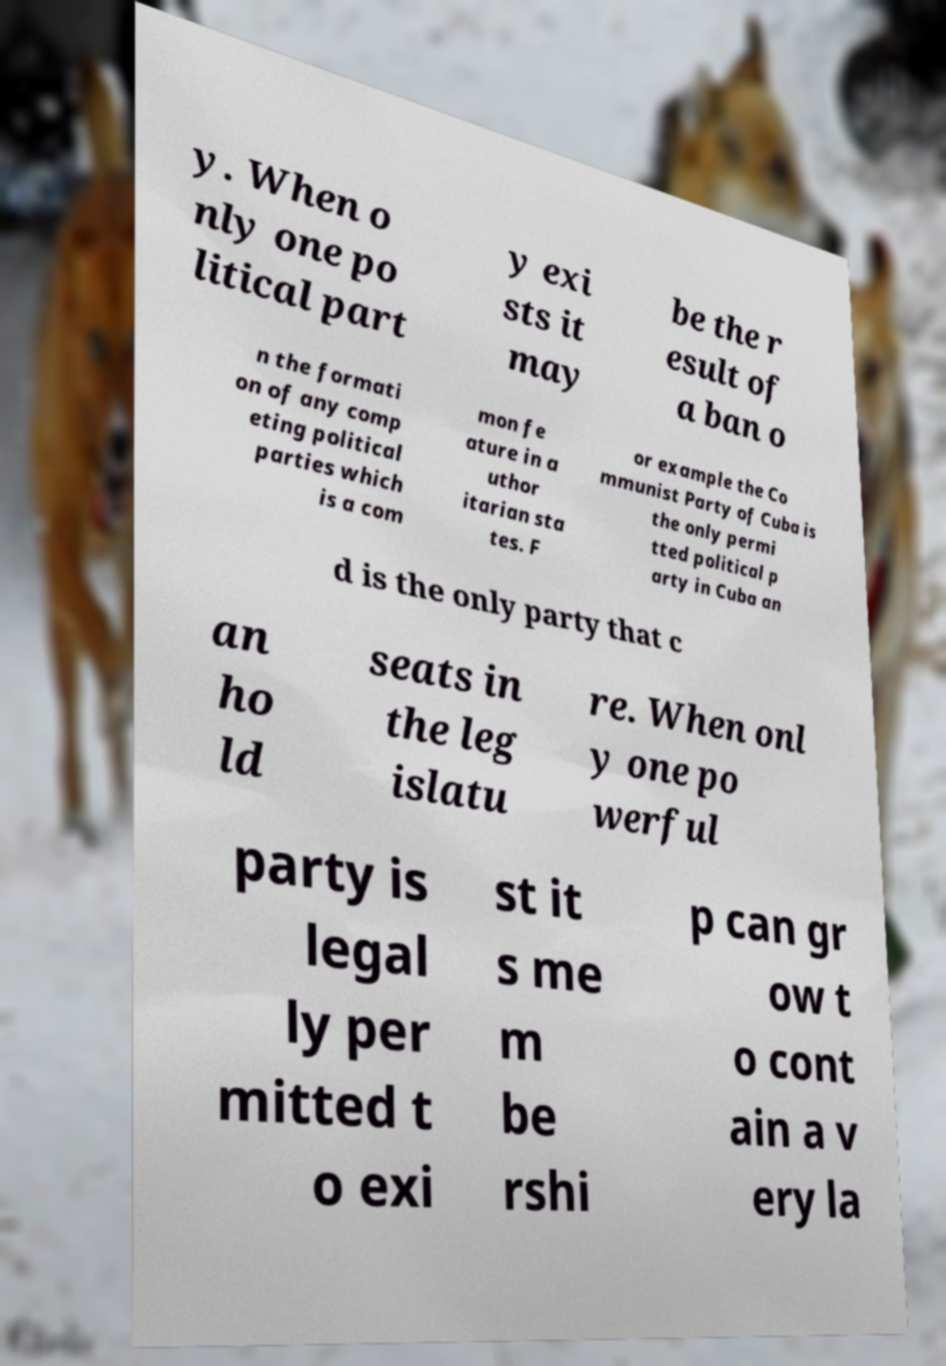Could you extract and type out the text from this image? y. When o nly one po litical part y exi sts it may be the r esult of a ban o n the formati on of any comp eting political parties which is a com mon fe ature in a uthor itarian sta tes. F or example the Co mmunist Party of Cuba is the only permi tted political p arty in Cuba an d is the only party that c an ho ld seats in the leg islatu re. When onl y one po werful party is legal ly per mitted t o exi st it s me m be rshi p can gr ow t o cont ain a v ery la 